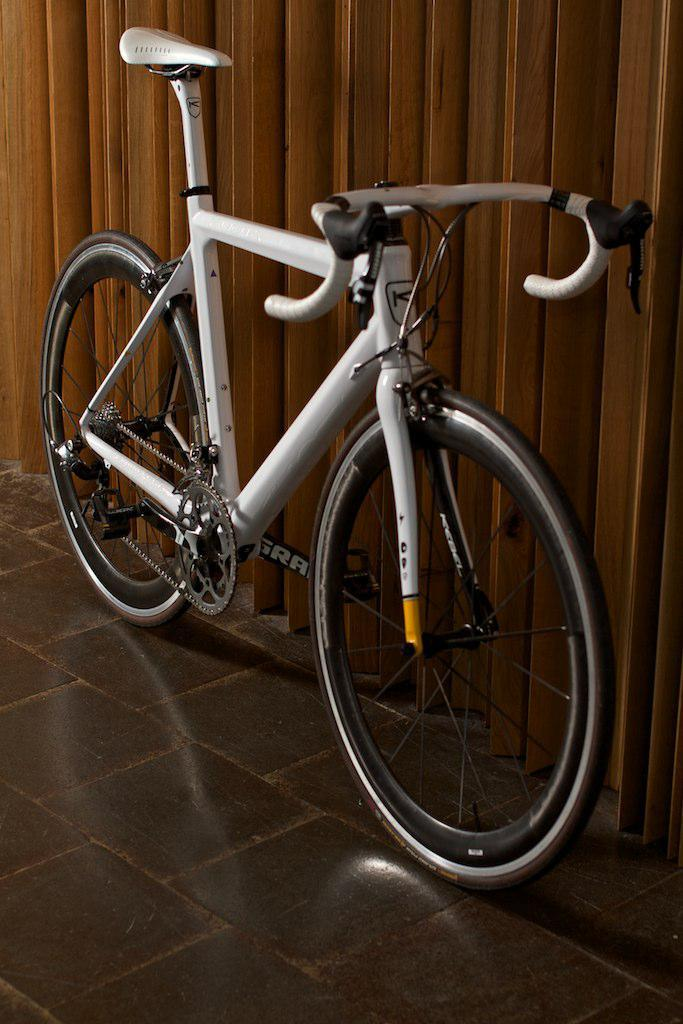What is the main object in the image? There is a bicycle in the image. Where is the bicycle located? The bicycle is on the floor. How many dinosaurs are riding the bicycle in the image? There are no dinosaurs present in the image, and therefore none are riding the bicycle. What type of squirrel can be seen holding a store sign in the image? There is no squirrel or store sign present in the image. 